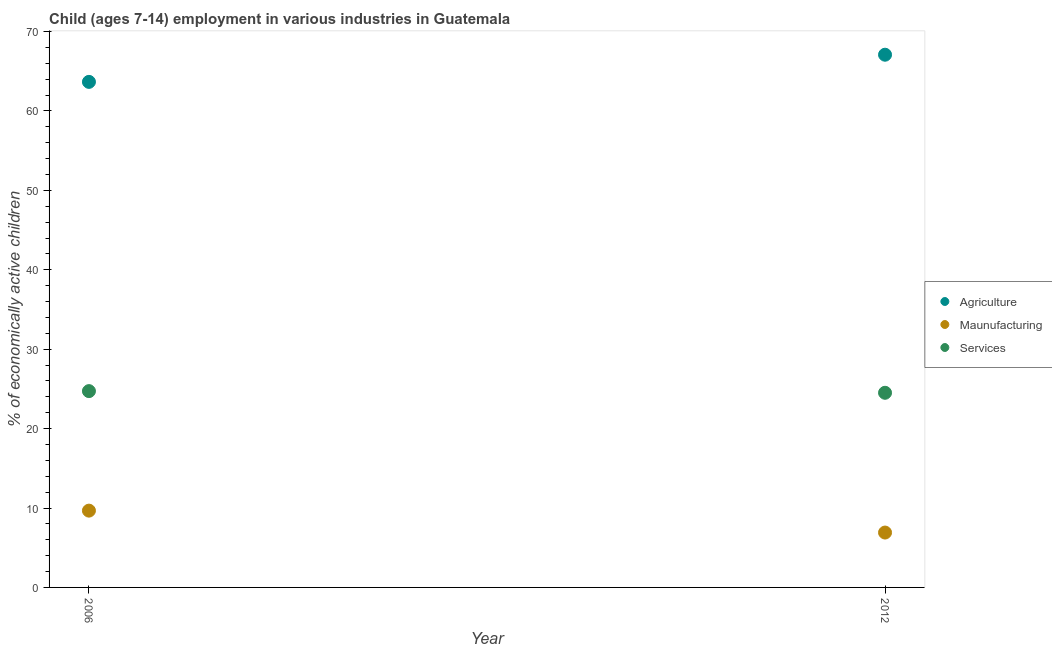Is the number of dotlines equal to the number of legend labels?
Give a very brief answer. Yes. What is the percentage of economically active children in services in 2012?
Make the answer very short. 24.51. Across all years, what is the maximum percentage of economically active children in agriculture?
Your answer should be very brief. 67.08. Across all years, what is the minimum percentage of economically active children in agriculture?
Make the answer very short. 63.66. What is the total percentage of economically active children in agriculture in the graph?
Your answer should be compact. 130.74. What is the difference between the percentage of economically active children in manufacturing in 2006 and that in 2012?
Offer a very short reply. 2.76. What is the difference between the percentage of economically active children in agriculture in 2006 and the percentage of economically active children in services in 2012?
Make the answer very short. 39.15. What is the average percentage of economically active children in agriculture per year?
Keep it short and to the point. 65.37. In the year 2012, what is the difference between the percentage of economically active children in manufacturing and percentage of economically active children in agriculture?
Your answer should be compact. -60.17. In how many years, is the percentage of economically active children in agriculture greater than 16 %?
Keep it short and to the point. 2. What is the ratio of the percentage of economically active children in services in 2006 to that in 2012?
Make the answer very short. 1.01. In how many years, is the percentage of economically active children in agriculture greater than the average percentage of economically active children in agriculture taken over all years?
Make the answer very short. 1. Does the percentage of economically active children in agriculture monotonically increase over the years?
Provide a succinct answer. Yes. Is the percentage of economically active children in services strictly less than the percentage of economically active children in manufacturing over the years?
Make the answer very short. No. How many dotlines are there?
Keep it short and to the point. 3. What is the difference between two consecutive major ticks on the Y-axis?
Give a very brief answer. 10. Are the values on the major ticks of Y-axis written in scientific E-notation?
Offer a very short reply. No. Does the graph contain any zero values?
Provide a succinct answer. No. Does the graph contain grids?
Provide a succinct answer. No. Where does the legend appear in the graph?
Keep it short and to the point. Center right. How are the legend labels stacked?
Your answer should be compact. Vertical. What is the title of the graph?
Provide a short and direct response. Child (ages 7-14) employment in various industries in Guatemala. What is the label or title of the Y-axis?
Give a very brief answer. % of economically active children. What is the % of economically active children in Agriculture in 2006?
Offer a very short reply. 63.66. What is the % of economically active children of Maunufacturing in 2006?
Keep it short and to the point. 9.67. What is the % of economically active children of Services in 2006?
Make the answer very short. 24.72. What is the % of economically active children of Agriculture in 2012?
Ensure brevity in your answer.  67.08. What is the % of economically active children of Maunufacturing in 2012?
Ensure brevity in your answer.  6.91. What is the % of economically active children of Services in 2012?
Offer a very short reply. 24.51. Across all years, what is the maximum % of economically active children in Agriculture?
Offer a terse response. 67.08. Across all years, what is the maximum % of economically active children of Maunufacturing?
Make the answer very short. 9.67. Across all years, what is the maximum % of economically active children in Services?
Your answer should be very brief. 24.72. Across all years, what is the minimum % of economically active children of Agriculture?
Provide a succinct answer. 63.66. Across all years, what is the minimum % of economically active children in Maunufacturing?
Offer a very short reply. 6.91. Across all years, what is the minimum % of economically active children of Services?
Give a very brief answer. 24.51. What is the total % of economically active children of Agriculture in the graph?
Provide a succinct answer. 130.74. What is the total % of economically active children in Maunufacturing in the graph?
Keep it short and to the point. 16.58. What is the total % of economically active children of Services in the graph?
Your answer should be compact. 49.23. What is the difference between the % of economically active children in Agriculture in 2006 and that in 2012?
Keep it short and to the point. -3.42. What is the difference between the % of economically active children in Maunufacturing in 2006 and that in 2012?
Provide a succinct answer. 2.76. What is the difference between the % of economically active children of Services in 2006 and that in 2012?
Give a very brief answer. 0.21. What is the difference between the % of economically active children in Agriculture in 2006 and the % of economically active children in Maunufacturing in 2012?
Provide a succinct answer. 56.75. What is the difference between the % of economically active children of Agriculture in 2006 and the % of economically active children of Services in 2012?
Make the answer very short. 39.15. What is the difference between the % of economically active children in Maunufacturing in 2006 and the % of economically active children in Services in 2012?
Provide a short and direct response. -14.84. What is the average % of economically active children in Agriculture per year?
Give a very brief answer. 65.37. What is the average % of economically active children of Maunufacturing per year?
Give a very brief answer. 8.29. What is the average % of economically active children in Services per year?
Provide a succinct answer. 24.61. In the year 2006, what is the difference between the % of economically active children in Agriculture and % of economically active children in Maunufacturing?
Your answer should be very brief. 53.99. In the year 2006, what is the difference between the % of economically active children of Agriculture and % of economically active children of Services?
Your answer should be compact. 38.94. In the year 2006, what is the difference between the % of economically active children of Maunufacturing and % of economically active children of Services?
Offer a terse response. -15.05. In the year 2012, what is the difference between the % of economically active children of Agriculture and % of economically active children of Maunufacturing?
Your answer should be compact. 60.17. In the year 2012, what is the difference between the % of economically active children of Agriculture and % of economically active children of Services?
Make the answer very short. 42.57. In the year 2012, what is the difference between the % of economically active children in Maunufacturing and % of economically active children in Services?
Keep it short and to the point. -17.6. What is the ratio of the % of economically active children of Agriculture in 2006 to that in 2012?
Keep it short and to the point. 0.95. What is the ratio of the % of economically active children of Maunufacturing in 2006 to that in 2012?
Your answer should be compact. 1.4. What is the ratio of the % of economically active children of Services in 2006 to that in 2012?
Give a very brief answer. 1.01. What is the difference between the highest and the second highest % of economically active children of Agriculture?
Your answer should be very brief. 3.42. What is the difference between the highest and the second highest % of economically active children of Maunufacturing?
Provide a succinct answer. 2.76. What is the difference between the highest and the second highest % of economically active children of Services?
Offer a terse response. 0.21. What is the difference between the highest and the lowest % of economically active children of Agriculture?
Provide a short and direct response. 3.42. What is the difference between the highest and the lowest % of economically active children in Maunufacturing?
Keep it short and to the point. 2.76. What is the difference between the highest and the lowest % of economically active children in Services?
Offer a very short reply. 0.21. 